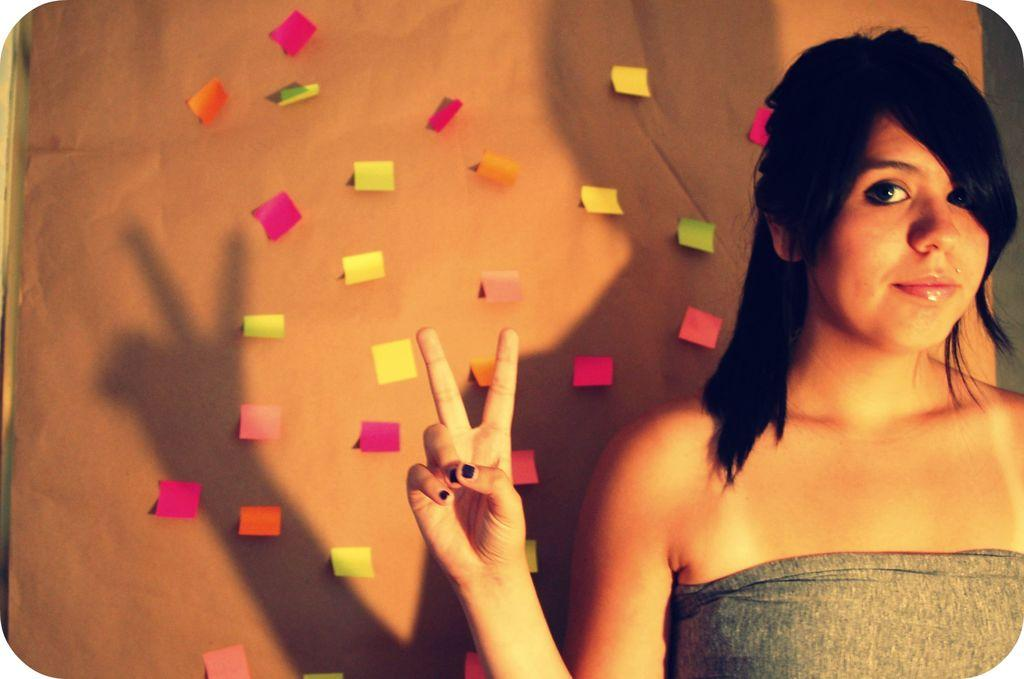What is the main subject in the image? There is a woman standing in the image. Can you describe any objects or features in the background or surrounding the woman? Yes, there are paper clips on the wall in the image. What type of picture is the woman holding in the image? There is no picture visible in the image; the woman is not holding anything. 